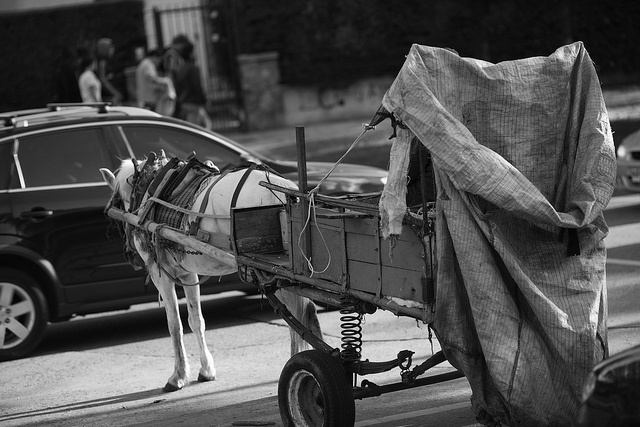Describe the objects in this image and their specific colors. I can see car in gray, black, darkgray, and lightgray tones, horse in gray, darkgray, black, and lightgray tones, people in black and gray tones, people in gray, black, and lightgray tones, and people in black and gray tones in this image. 